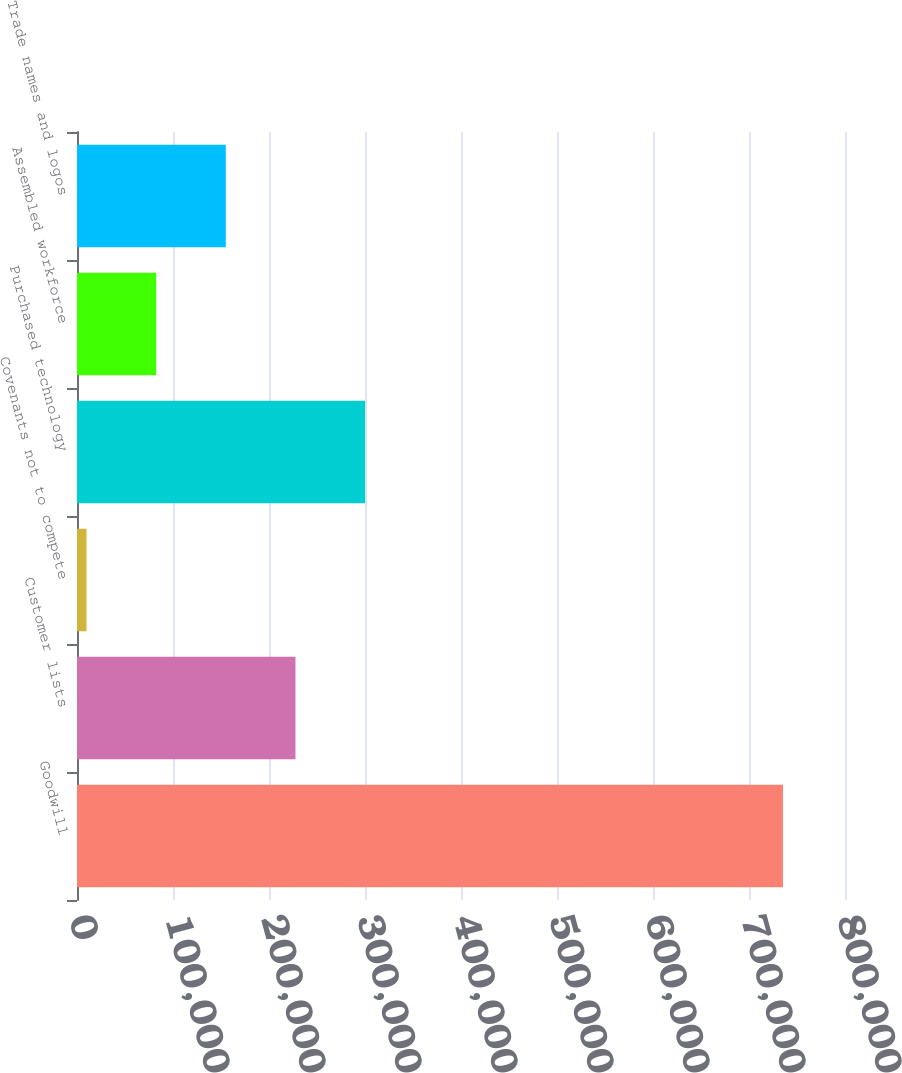<chart> <loc_0><loc_0><loc_500><loc_500><bar_chart><fcel>Goodwill<fcel>Customer lists<fcel>Covenants not to compete<fcel>Purchased technology<fcel>Assembled workforce<fcel>Trade names and logos<nl><fcel>735393<fcel>227560<fcel>9917<fcel>300107<fcel>82464.6<fcel>155012<nl></chart> 